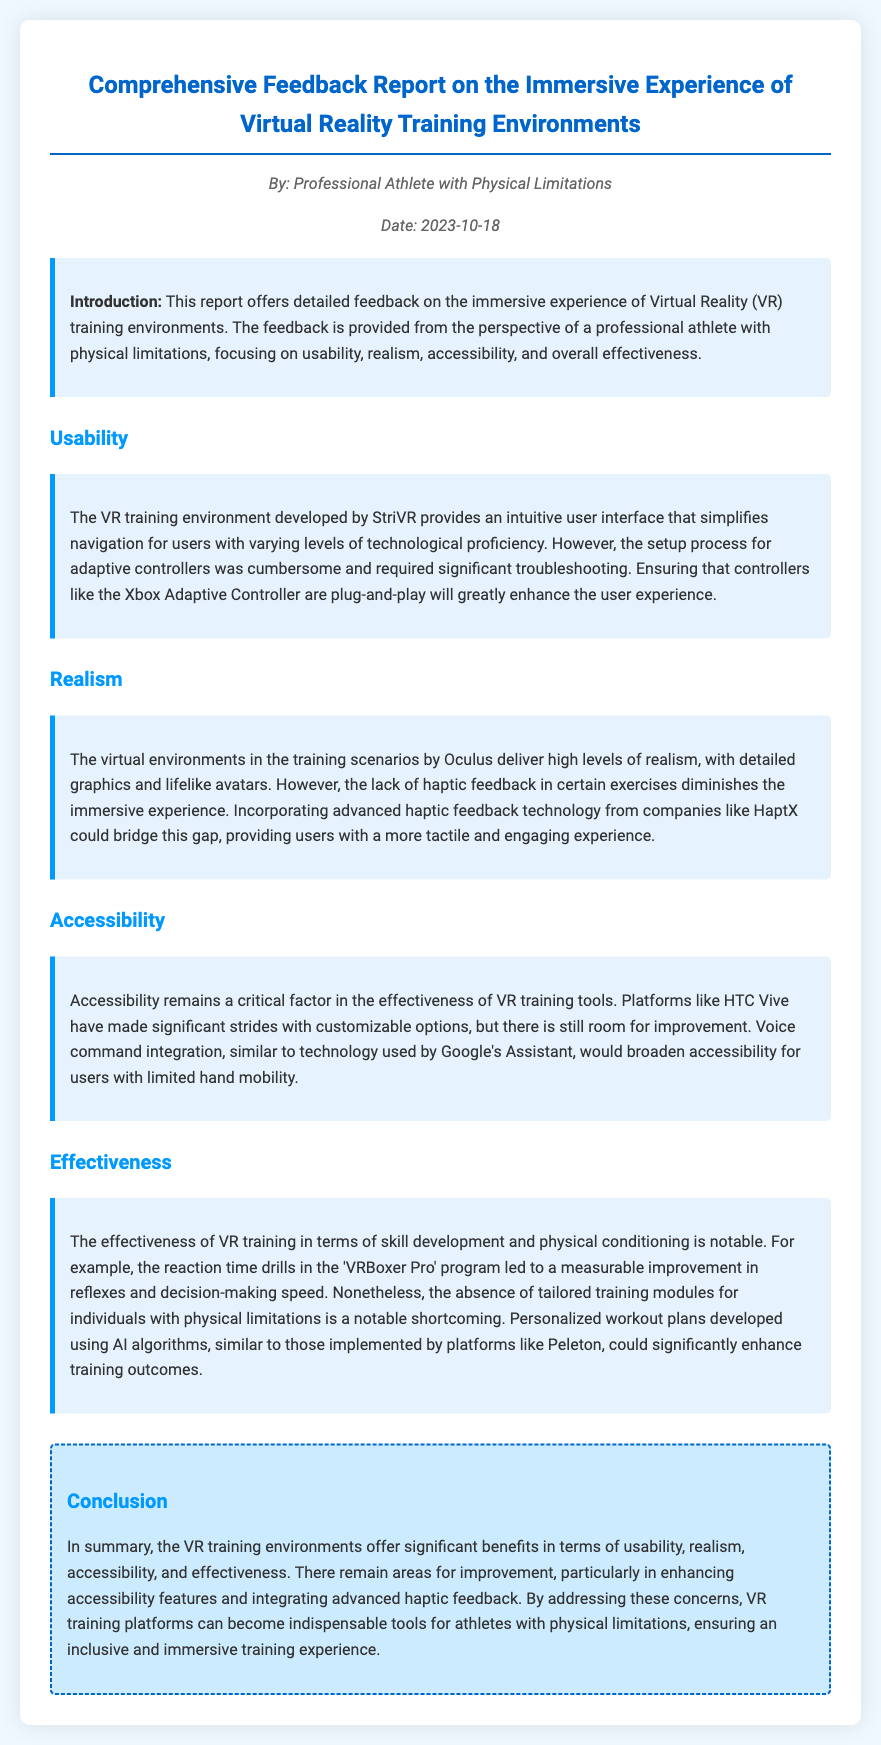what is the title of the report? The title of the report is mentioned at the beginning of the document, which outlines the focus on VR training environments.
Answer: Comprehensive Feedback Report on the Immersive Experience of Virtual Reality Training Environments who authored the report? The author of the report is specified in the document, indicating their perspective and experience.
Answer: Professional Athlete with Physical Limitations when was the report published? The publication date is clearly mentioned in the document under the author information.
Answer: 2023-10-18 which company's VR training environment is mentioned for usability? The document discusses the usability aspects of VR training environments, specifically naming the relevant company.
Answer: StriVR what is a suggested improvement for realism in VR training? The report highlights a particular technological enhancement that could improve the realism of VR scenarios.
Answer: Advanced haptic feedback technology what aspect of accessibility is noted for improvement? In the accessibility section, a specific technology is proposed to enhance user experiences for those with limitations.
Answer: Voice command integration what measurable improvement was noted in the effectiveness section? The document outlines an observable and quantifiable enhancement resulting from using a specific program.
Answer: Improvement in reflexes and decision-making speed what is a notable shortcoming mentioned in the effectiveness section? A specific criticism regarding training modules for individuals with physical limitations is identified in the effectiveness section.
Answer: Absence of tailored training modules how does the report conclude on the overall effectiveness of VR training environments? The conclusion summarizes the overall benefits identified throughout the document in various areas of usability and effectiveness.
Answer: Significant benefits in terms of usability, realism, accessibility, and effectiveness 